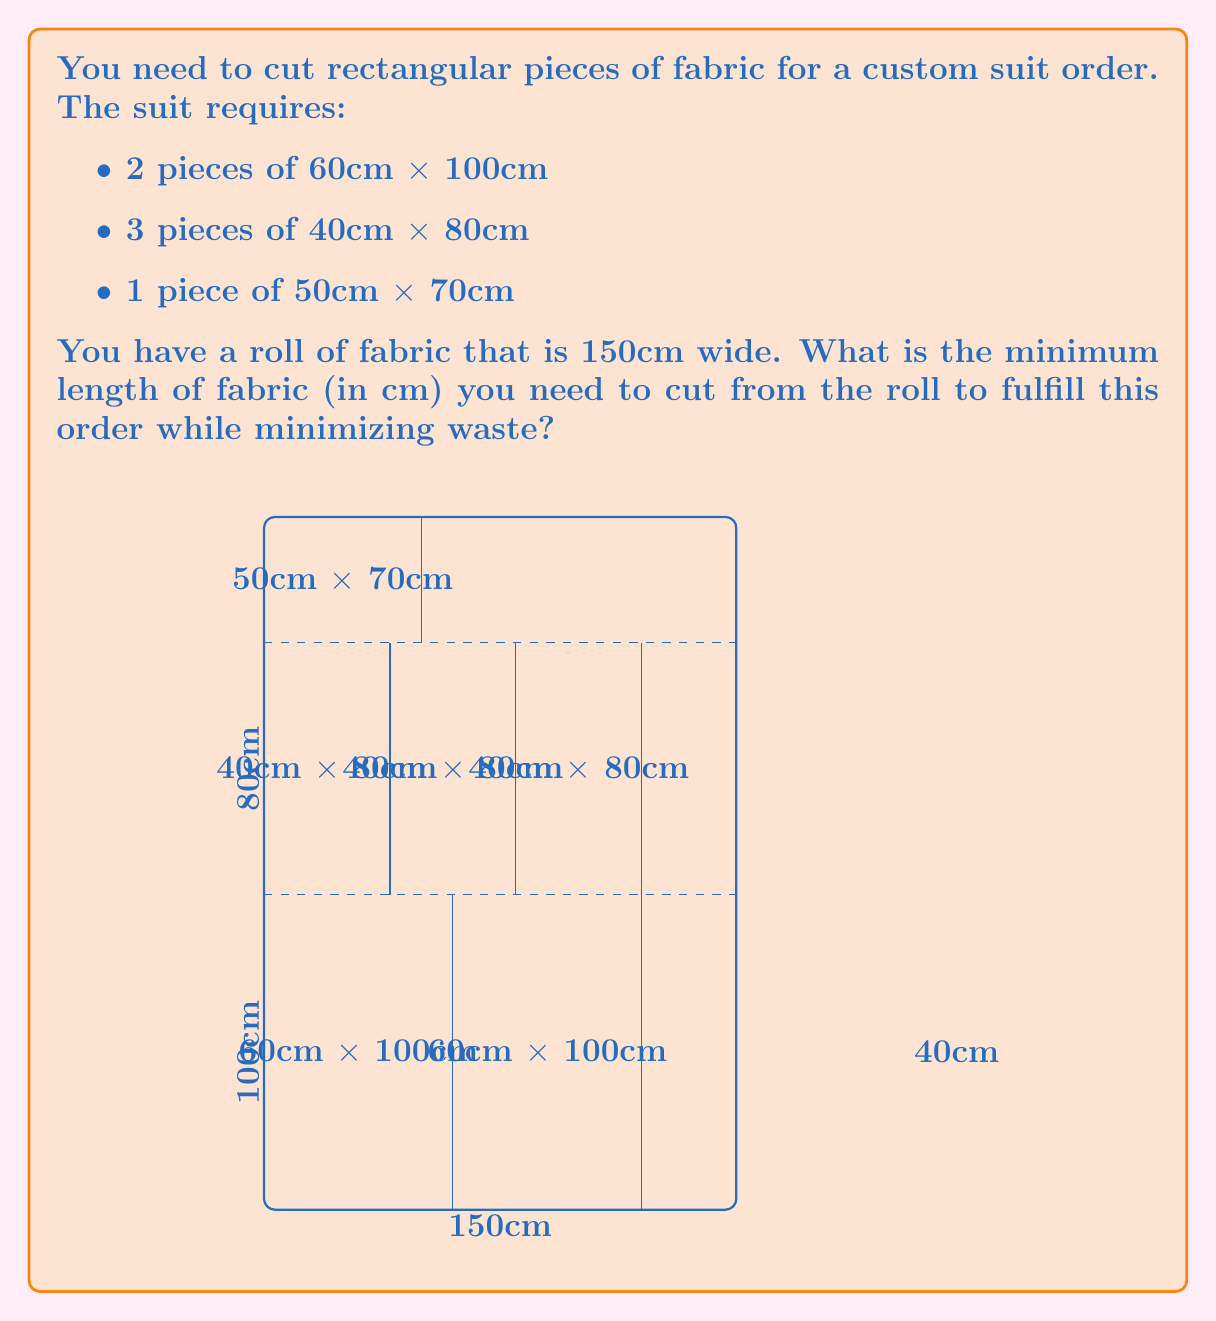Show me your answer to this math problem. Let's approach this step-by-step:

1) First, we need to arrange the pieces efficiently on the 150cm wide fabric.

2) The largest pieces are 60cm x 100cm. We can fit two of these side by side on the 150cm width (60cm + 60cm = 120cm < 150cm).

3) For the 40cm x 80cm pieces, we can fit three of them side by side (40cm + 40cm + 40cm = 120cm < 150cm).

4) The 50cm x 70cm piece can be placed separately.

5) Now, let's calculate the length needed:
   - For the two 60cm x 100cm pieces: 100cm
   - For the three 40cm x 80cm pieces: 80cm
   - For the 50cm x 70cm piece: 70cm

6) Total length required: 100cm + 80cm + 70cm = 250cm

7) However, we can optimize further. The 50cm x 70cm piece can fit in the 30cm space left beside the 60cm x 100cm pieces.

8) So, our final arrangement requires:
   - 100cm for the two 60cm x 100cm pieces (with the 50cm x 70cm piece beside them)
   - 80cm for the three 40cm x 80cm pieces

9) The total optimized length is thus: 100cm + 80cm = 180cm

Therefore, the minimum length of fabric needed is 180cm.
Answer: 180cm 